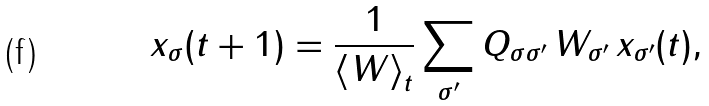<formula> <loc_0><loc_0><loc_500><loc_500>x _ { \sigma } ( t + 1 ) = \frac { 1 } { \left < W \right > _ { t } } \sum _ { \sigma ^ { \prime } } Q _ { \sigma \sigma ^ { \prime } } \, W _ { \sigma ^ { \prime } } \, x _ { \sigma ^ { \prime } } ( t ) ,</formula> 